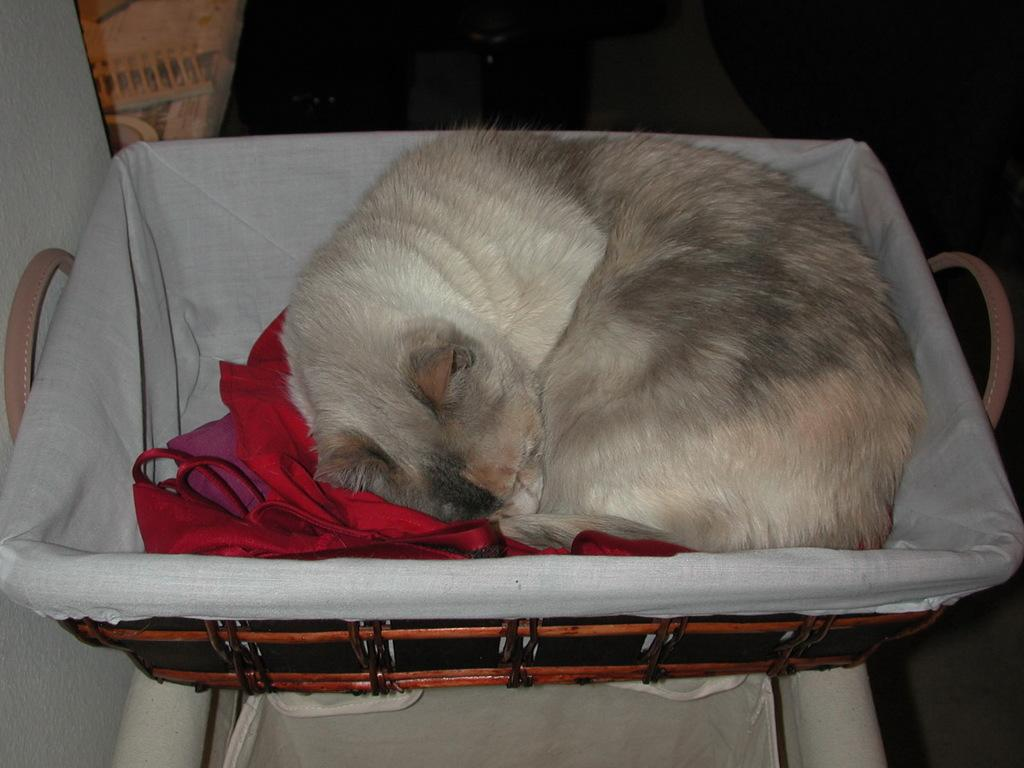What type of animal can be seen in the image? There is a cat in the image. Where is the cat located in the image? The cat is laying in a basket. What object is the cat laying in? The basket is present in the image. How many boys are playing guitar in the image? There are no boys or guitars present in the image; it features a cat laying in a basket. 